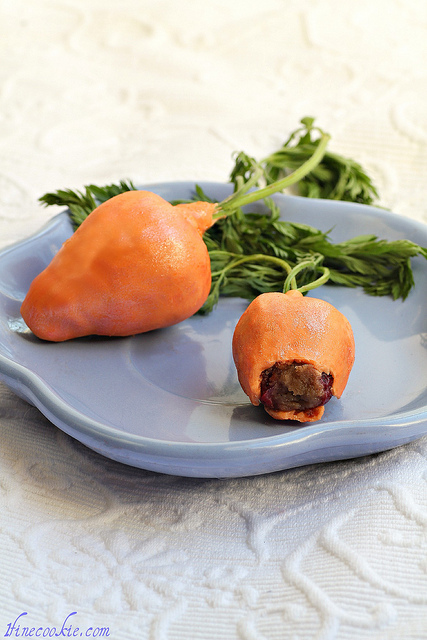Read all the text in this image. Vinecookie.com 